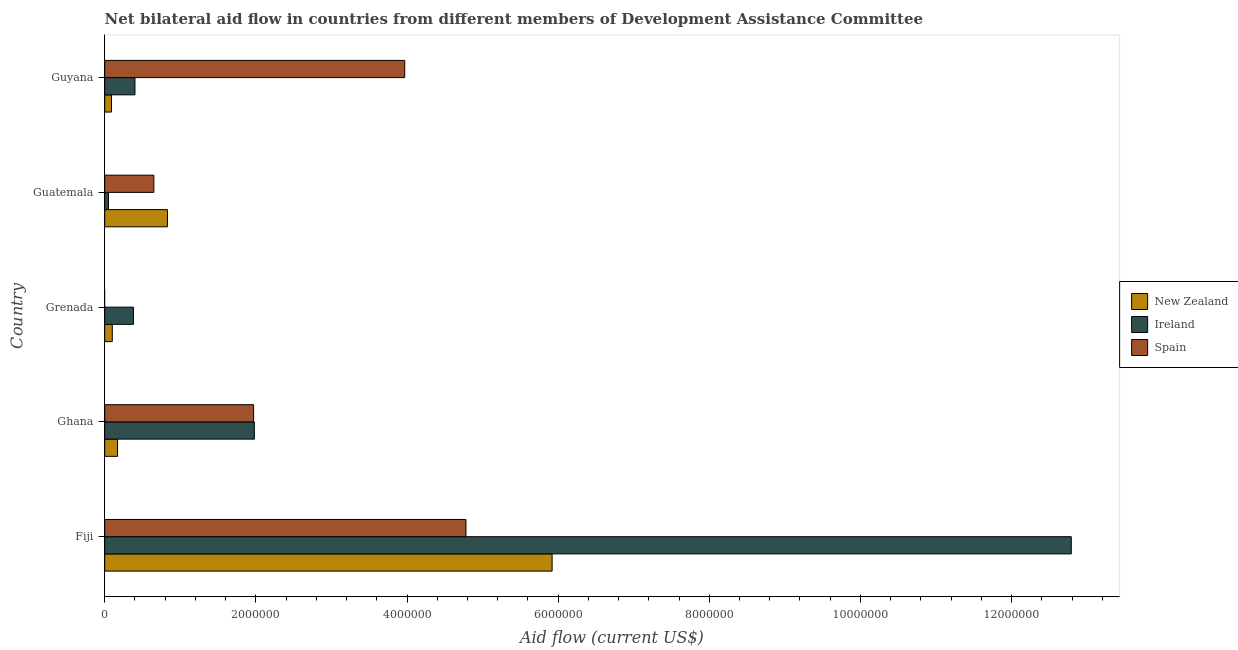How many different coloured bars are there?
Provide a succinct answer. 3. How many groups of bars are there?
Your answer should be compact. 5. Are the number of bars per tick equal to the number of legend labels?
Your response must be concise. No. Are the number of bars on each tick of the Y-axis equal?
Provide a short and direct response. No. How many bars are there on the 4th tick from the top?
Offer a terse response. 3. What is the label of the 2nd group of bars from the top?
Provide a short and direct response. Guatemala. What is the amount of aid provided by new zealand in Guyana?
Give a very brief answer. 9.00e+04. Across all countries, what is the maximum amount of aid provided by ireland?
Give a very brief answer. 1.28e+07. Across all countries, what is the minimum amount of aid provided by new zealand?
Offer a very short reply. 9.00e+04. In which country was the amount of aid provided by ireland maximum?
Your answer should be very brief. Fiji. What is the total amount of aid provided by spain in the graph?
Ensure brevity in your answer.  1.14e+07. What is the difference between the amount of aid provided by new zealand in Fiji and that in Guyana?
Your answer should be very brief. 5.83e+06. What is the difference between the amount of aid provided by spain in Guatemala and the amount of aid provided by new zealand in Fiji?
Your answer should be very brief. -5.27e+06. What is the average amount of aid provided by new zealand per country?
Offer a very short reply. 1.42e+06. What is the difference between the amount of aid provided by ireland and amount of aid provided by spain in Fiji?
Provide a succinct answer. 8.01e+06. What is the ratio of the amount of aid provided by ireland in Fiji to that in Grenada?
Your response must be concise. 33.66. Is the difference between the amount of aid provided by ireland in Ghana and Guatemala greater than the difference between the amount of aid provided by new zealand in Ghana and Guatemala?
Your response must be concise. Yes. What is the difference between the highest and the second highest amount of aid provided by ireland?
Your answer should be compact. 1.08e+07. What is the difference between the highest and the lowest amount of aid provided by new zealand?
Offer a terse response. 5.83e+06. In how many countries, is the amount of aid provided by ireland greater than the average amount of aid provided by ireland taken over all countries?
Keep it short and to the point. 1. Is the sum of the amount of aid provided by ireland in Grenada and Guyana greater than the maximum amount of aid provided by new zealand across all countries?
Provide a short and direct response. No. Is it the case that in every country, the sum of the amount of aid provided by new zealand and amount of aid provided by ireland is greater than the amount of aid provided by spain?
Provide a succinct answer. No. Are all the bars in the graph horizontal?
Provide a succinct answer. Yes. How many countries are there in the graph?
Your answer should be compact. 5. Does the graph contain any zero values?
Offer a terse response. Yes. Does the graph contain grids?
Ensure brevity in your answer.  No. Where does the legend appear in the graph?
Offer a very short reply. Center right. What is the title of the graph?
Give a very brief answer. Net bilateral aid flow in countries from different members of Development Assistance Committee. Does "Male employers" appear as one of the legend labels in the graph?
Ensure brevity in your answer.  No. What is the Aid flow (current US$) of New Zealand in Fiji?
Give a very brief answer. 5.92e+06. What is the Aid flow (current US$) of Ireland in Fiji?
Offer a very short reply. 1.28e+07. What is the Aid flow (current US$) of Spain in Fiji?
Provide a short and direct response. 4.78e+06. What is the Aid flow (current US$) in New Zealand in Ghana?
Your answer should be compact. 1.70e+05. What is the Aid flow (current US$) of Ireland in Ghana?
Give a very brief answer. 1.98e+06. What is the Aid flow (current US$) in Spain in Ghana?
Your answer should be compact. 1.97e+06. What is the Aid flow (current US$) of New Zealand in Grenada?
Provide a short and direct response. 1.00e+05. What is the Aid flow (current US$) in Ireland in Grenada?
Give a very brief answer. 3.80e+05. What is the Aid flow (current US$) of Spain in Grenada?
Make the answer very short. 0. What is the Aid flow (current US$) of New Zealand in Guatemala?
Your response must be concise. 8.30e+05. What is the Aid flow (current US$) in Spain in Guatemala?
Offer a very short reply. 6.50e+05. What is the Aid flow (current US$) of New Zealand in Guyana?
Offer a terse response. 9.00e+04. What is the Aid flow (current US$) of Ireland in Guyana?
Your answer should be very brief. 4.00e+05. What is the Aid flow (current US$) in Spain in Guyana?
Offer a very short reply. 3.97e+06. Across all countries, what is the maximum Aid flow (current US$) of New Zealand?
Offer a very short reply. 5.92e+06. Across all countries, what is the maximum Aid flow (current US$) in Ireland?
Offer a very short reply. 1.28e+07. Across all countries, what is the maximum Aid flow (current US$) in Spain?
Your answer should be very brief. 4.78e+06. Across all countries, what is the minimum Aid flow (current US$) in New Zealand?
Make the answer very short. 9.00e+04. What is the total Aid flow (current US$) in New Zealand in the graph?
Offer a very short reply. 7.11e+06. What is the total Aid flow (current US$) in Ireland in the graph?
Your answer should be compact. 1.56e+07. What is the total Aid flow (current US$) of Spain in the graph?
Keep it short and to the point. 1.14e+07. What is the difference between the Aid flow (current US$) of New Zealand in Fiji and that in Ghana?
Make the answer very short. 5.75e+06. What is the difference between the Aid flow (current US$) of Ireland in Fiji and that in Ghana?
Your answer should be compact. 1.08e+07. What is the difference between the Aid flow (current US$) of Spain in Fiji and that in Ghana?
Give a very brief answer. 2.81e+06. What is the difference between the Aid flow (current US$) of New Zealand in Fiji and that in Grenada?
Offer a very short reply. 5.82e+06. What is the difference between the Aid flow (current US$) in Ireland in Fiji and that in Grenada?
Make the answer very short. 1.24e+07. What is the difference between the Aid flow (current US$) of New Zealand in Fiji and that in Guatemala?
Provide a short and direct response. 5.09e+06. What is the difference between the Aid flow (current US$) of Ireland in Fiji and that in Guatemala?
Give a very brief answer. 1.27e+07. What is the difference between the Aid flow (current US$) in Spain in Fiji and that in Guatemala?
Offer a terse response. 4.13e+06. What is the difference between the Aid flow (current US$) of New Zealand in Fiji and that in Guyana?
Give a very brief answer. 5.83e+06. What is the difference between the Aid flow (current US$) of Ireland in Fiji and that in Guyana?
Offer a terse response. 1.24e+07. What is the difference between the Aid flow (current US$) in Spain in Fiji and that in Guyana?
Your answer should be compact. 8.10e+05. What is the difference between the Aid flow (current US$) in New Zealand in Ghana and that in Grenada?
Your answer should be compact. 7.00e+04. What is the difference between the Aid flow (current US$) in Ireland in Ghana and that in Grenada?
Provide a short and direct response. 1.60e+06. What is the difference between the Aid flow (current US$) in New Zealand in Ghana and that in Guatemala?
Your answer should be compact. -6.60e+05. What is the difference between the Aid flow (current US$) of Ireland in Ghana and that in Guatemala?
Your answer should be very brief. 1.93e+06. What is the difference between the Aid flow (current US$) of Spain in Ghana and that in Guatemala?
Keep it short and to the point. 1.32e+06. What is the difference between the Aid flow (current US$) in Ireland in Ghana and that in Guyana?
Give a very brief answer. 1.58e+06. What is the difference between the Aid flow (current US$) of New Zealand in Grenada and that in Guatemala?
Give a very brief answer. -7.30e+05. What is the difference between the Aid flow (current US$) of New Zealand in Grenada and that in Guyana?
Your answer should be very brief. 10000. What is the difference between the Aid flow (current US$) in Ireland in Grenada and that in Guyana?
Ensure brevity in your answer.  -2.00e+04. What is the difference between the Aid flow (current US$) in New Zealand in Guatemala and that in Guyana?
Ensure brevity in your answer.  7.40e+05. What is the difference between the Aid flow (current US$) in Ireland in Guatemala and that in Guyana?
Your answer should be compact. -3.50e+05. What is the difference between the Aid flow (current US$) in Spain in Guatemala and that in Guyana?
Keep it short and to the point. -3.32e+06. What is the difference between the Aid flow (current US$) in New Zealand in Fiji and the Aid flow (current US$) in Ireland in Ghana?
Offer a very short reply. 3.94e+06. What is the difference between the Aid flow (current US$) in New Zealand in Fiji and the Aid flow (current US$) in Spain in Ghana?
Offer a very short reply. 3.95e+06. What is the difference between the Aid flow (current US$) of Ireland in Fiji and the Aid flow (current US$) of Spain in Ghana?
Provide a short and direct response. 1.08e+07. What is the difference between the Aid flow (current US$) in New Zealand in Fiji and the Aid flow (current US$) in Ireland in Grenada?
Provide a succinct answer. 5.54e+06. What is the difference between the Aid flow (current US$) of New Zealand in Fiji and the Aid flow (current US$) of Ireland in Guatemala?
Give a very brief answer. 5.87e+06. What is the difference between the Aid flow (current US$) of New Zealand in Fiji and the Aid flow (current US$) of Spain in Guatemala?
Ensure brevity in your answer.  5.27e+06. What is the difference between the Aid flow (current US$) in Ireland in Fiji and the Aid flow (current US$) in Spain in Guatemala?
Your answer should be very brief. 1.21e+07. What is the difference between the Aid flow (current US$) of New Zealand in Fiji and the Aid flow (current US$) of Ireland in Guyana?
Ensure brevity in your answer.  5.52e+06. What is the difference between the Aid flow (current US$) of New Zealand in Fiji and the Aid flow (current US$) of Spain in Guyana?
Provide a succinct answer. 1.95e+06. What is the difference between the Aid flow (current US$) of Ireland in Fiji and the Aid flow (current US$) of Spain in Guyana?
Keep it short and to the point. 8.82e+06. What is the difference between the Aid flow (current US$) in New Zealand in Ghana and the Aid flow (current US$) in Ireland in Grenada?
Provide a short and direct response. -2.10e+05. What is the difference between the Aid flow (current US$) of New Zealand in Ghana and the Aid flow (current US$) of Spain in Guatemala?
Offer a very short reply. -4.80e+05. What is the difference between the Aid flow (current US$) of Ireland in Ghana and the Aid flow (current US$) of Spain in Guatemala?
Ensure brevity in your answer.  1.33e+06. What is the difference between the Aid flow (current US$) of New Zealand in Ghana and the Aid flow (current US$) of Spain in Guyana?
Offer a very short reply. -3.80e+06. What is the difference between the Aid flow (current US$) of Ireland in Ghana and the Aid flow (current US$) of Spain in Guyana?
Ensure brevity in your answer.  -1.99e+06. What is the difference between the Aid flow (current US$) of New Zealand in Grenada and the Aid flow (current US$) of Spain in Guatemala?
Provide a short and direct response. -5.50e+05. What is the difference between the Aid flow (current US$) of New Zealand in Grenada and the Aid flow (current US$) of Spain in Guyana?
Your answer should be very brief. -3.87e+06. What is the difference between the Aid flow (current US$) of Ireland in Grenada and the Aid flow (current US$) of Spain in Guyana?
Give a very brief answer. -3.59e+06. What is the difference between the Aid flow (current US$) of New Zealand in Guatemala and the Aid flow (current US$) of Spain in Guyana?
Keep it short and to the point. -3.14e+06. What is the difference between the Aid flow (current US$) in Ireland in Guatemala and the Aid flow (current US$) in Spain in Guyana?
Offer a terse response. -3.92e+06. What is the average Aid flow (current US$) of New Zealand per country?
Your response must be concise. 1.42e+06. What is the average Aid flow (current US$) of Ireland per country?
Ensure brevity in your answer.  3.12e+06. What is the average Aid flow (current US$) in Spain per country?
Ensure brevity in your answer.  2.27e+06. What is the difference between the Aid flow (current US$) in New Zealand and Aid flow (current US$) in Ireland in Fiji?
Make the answer very short. -6.87e+06. What is the difference between the Aid flow (current US$) of New Zealand and Aid flow (current US$) of Spain in Fiji?
Your answer should be very brief. 1.14e+06. What is the difference between the Aid flow (current US$) of Ireland and Aid flow (current US$) of Spain in Fiji?
Offer a terse response. 8.01e+06. What is the difference between the Aid flow (current US$) of New Zealand and Aid flow (current US$) of Ireland in Ghana?
Keep it short and to the point. -1.81e+06. What is the difference between the Aid flow (current US$) of New Zealand and Aid flow (current US$) of Spain in Ghana?
Offer a terse response. -1.80e+06. What is the difference between the Aid flow (current US$) in Ireland and Aid flow (current US$) in Spain in Ghana?
Your response must be concise. 10000. What is the difference between the Aid flow (current US$) in New Zealand and Aid flow (current US$) in Ireland in Grenada?
Your answer should be compact. -2.80e+05. What is the difference between the Aid flow (current US$) of New Zealand and Aid flow (current US$) of Ireland in Guatemala?
Your answer should be compact. 7.80e+05. What is the difference between the Aid flow (current US$) of Ireland and Aid flow (current US$) of Spain in Guatemala?
Your answer should be very brief. -6.00e+05. What is the difference between the Aid flow (current US$) of New Zealand and Aid flow (current US$) of Ireland in Guyana?
Provide a short and direct response. -3.10e+05. What is the difference between the Aid flow (current US$) in New Zealand and Aid flow (current US$) in Spain in Guyana?
Your answer should be very brief. -3.88e+06. What is the difference between the Aid flow (current US$) of Ireland and Aid flow (current US$) of Spain in Guyana?
Your answer should be very brief. -3.57e+06. What is the ratio of the Aid flow (current US$) in New Zealand in Fiji to that in Ghana?
Give a very brief answer. 34.82. What is the ratio of the Aid flow (current US$) of Ireland in Fiji to that in Ghana?
Ensure brevity in your answer.  6.46. What is the ratio of the Aid flow (current US$) in Spain in Fiji to that in Ghana?
Your response must be concise. 2.43. What is the ratio of the Aid flow (current US$) of New Zealand in Fiji to that in Grenada?
Offer a terse response. 59.2. What is the ratio of the Aid flow (current US$) of Ireland in Fiji to that in Grenada?
Provide a short and direct response. 33.66. What is the ratio of the Aid flow (current US$) in New Zealand in Fiji to that in Guatemala?
Make the answer very short. 7.13. What is the ratio of the Aid flow (current US$) in Ireland in Fiji to that in Guatemala?
Offer a very short reply. 255.8. What is the ratio of the Aid flow (current US$) in Spain in Fiji to that in Guatemala?
Your answer should be compact. 7.35. What is the ratio of the Aid flow (current US$) of New Zealand in Fiji to that in Guyana?
Offer a terse response. 65.78. What is the ratio of the Aid flow (current US$) in Ireland in Fiji to that in Guyana?
Provide a short and direct response. 31.98. What is the ratio of the Aid flow (current US$) in Spain in Fiji to that in Guyana?
Ensure brevity in your answer.  1.2. What is the ratio of the Aid flow (current US$) in Ireland in Ghana to that in Grenada?
Provide a succinct answer. 5.21. What is the ratio of the Aid flow (current US$) of New Zealand in Ghana to that in Guatemala?
Make the answer very short. 0.2. What is the ratio of the Aid flow (current US$) of Ireland in Ghana to that in Guatemala?
Your response must be concise. 39.6. What is the ratio of the Aid flow (current US$) of Spain in Ghana to that in Guatemala?
Offer a very short reply. 3.03. What is the ratio of the Aid flow (current US$) in New Zealand in Ghana to that in Guyana?
Provide a short and direct response. 1.89. What is the ratio of the Aid flow (current US$) of Ireland in Ghana to that in Guyana?
Your answer should be very brief. 4.95. What is the ratio of the Aid flow (current US$) of Spain in Ghana to that in Guyana?
Keep it short and to the point. 0.5. What is the ratio of the Aid flow (current US$) of New Zealand in Grenada to that in Guatemala?
Provide a succinct answer. 0.12. What is the ratio of the Aid flow (current US$) in Ireland in Grenada to that in Guatemala?
Make the answer very short. 7.6. What is the ratio of the Aid flow (current US$) of New Zealand in Grenada to that in Guyana?
Offer a terse response. 1.11. What is the ratio of the Aid flow (current US$) in New Zealand in Guatemala to that in Guyana?
Provide a short and direct response. 9.22. What is the ratio of the Aid flow (current US$) in Spain in Guatemala to that in Guyana?
Your answer should be very brief. 0.16. What is the difference between the highest and the second highest Aid flow (current US$) of New Zealand?
Offer a very short reply. 5.09e+06. What is the difference between the highest and the second highest Aid flow (current US$) of Ireland?
Keep it short and to the point. 1.08e+07. What is the difference between the highest and the second highest Aid flow (current US$) of Spain?
Offer a very short reply. 8.10e+05. What is the difference between the highest and the lowest Aid flow (current US$) in New Zealand?
Keep it short and to the point. 5.83e+06. What is the difference between the highest and the lowest Aid flow (current US$) of Ireland?
Your answer should be compact. 1.27e+07. What is the difference between the highest and the lowest Aid flow (current US$) of Spain?
Your answer should be compact. 4.78e+06. 